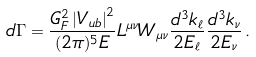<formula> <loc_0><loc_0><loc_500><loc_500>d \Gamma = \frac { G _ { F } ^ { 2 } \left | V _ { u b } \right | ^ { 2 } } { ( 2 \pi ) ^ { 5 } E } L ^ { \mu \nu } W _ { \mu \nu } \frac { d ^ { 3 } k _ { \ell } } { 2 E _ { \ell } } \frac { d ^ { 3 } k _ { \nu } } { 2 E _ { \nu } } \, .</formula> 